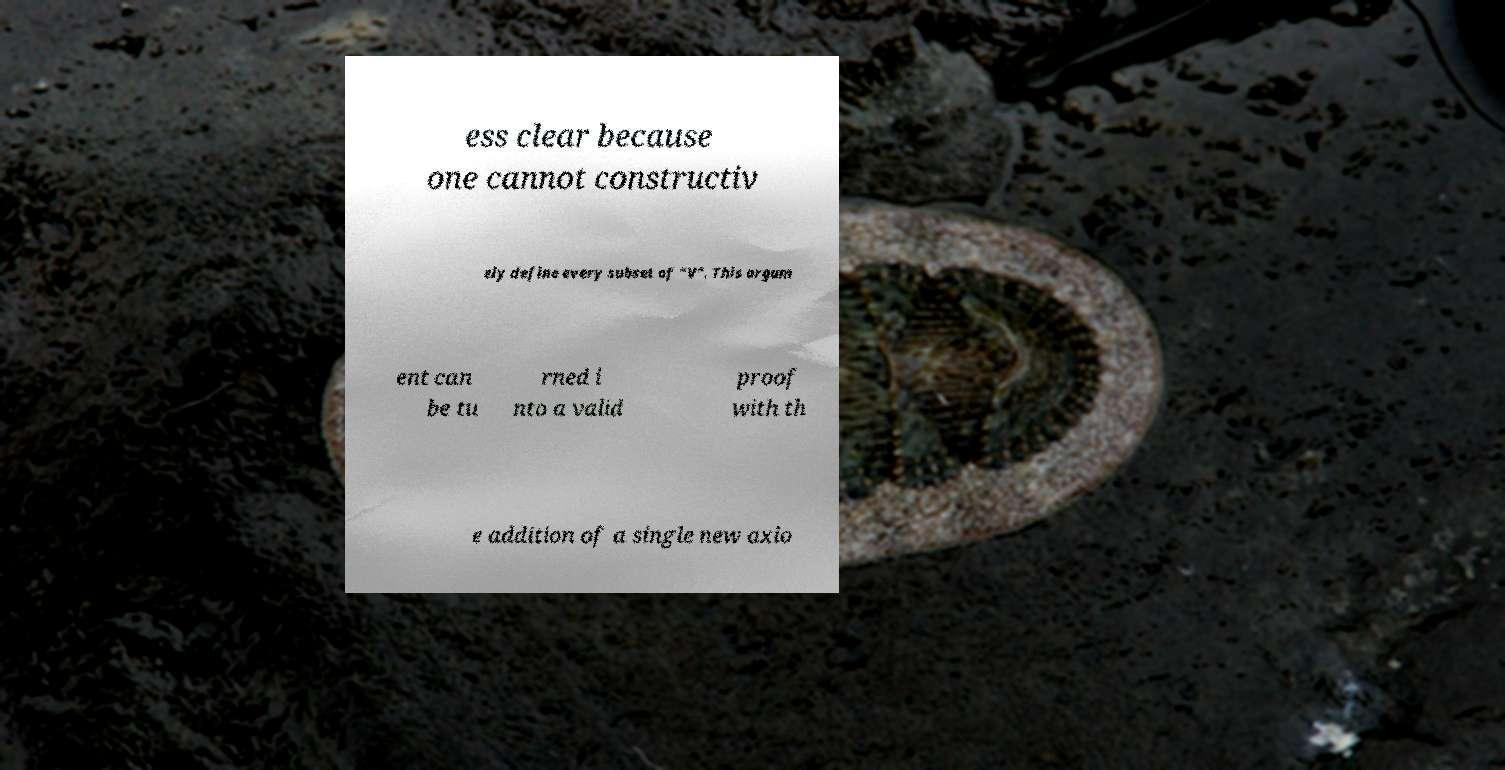What messages or text are displayed in this image? I need them in a readable, typed format. ess clear because one cannot constructiv ely define every subset of "V". This argum ent can be tu rned i nto a valid proof with th e addition of a single new axio 